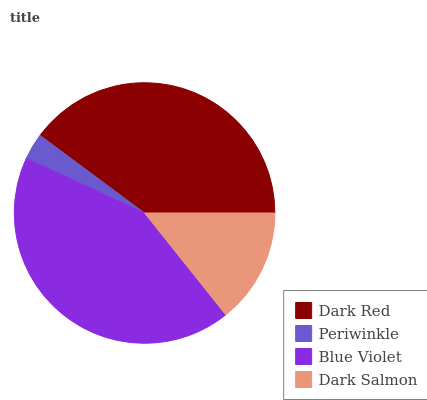Is Periwinkle the minimum?
Answer yes or no. Yes. Is Blue Violet the maximum?
Answer yes or no. Yes. Is Blue Violet the minimum?
Answer yes or no. No. Is Periwinkle the maximum?
Answer yes or no. No. Is Blue Violet greater than Periwinkle?
Answer yes or no. Yes. Is Periwinkle less than Blue Violet?
Answer yes or no. Yes. Is Periwinkle greater than Blue Violet?
Answer yes or no. No. Is Blue Violet less than Periwinkle?
Answer yes or no. No. Is Dark Red the high median?
Answer yes or no. Yes. Is Dark Salmon the low median?
Answer yes or no. Yes. Is Periwinkle the high median?
Answer yes or no. No. Is Periwinkle the low median?
Answer yes or no. No. 